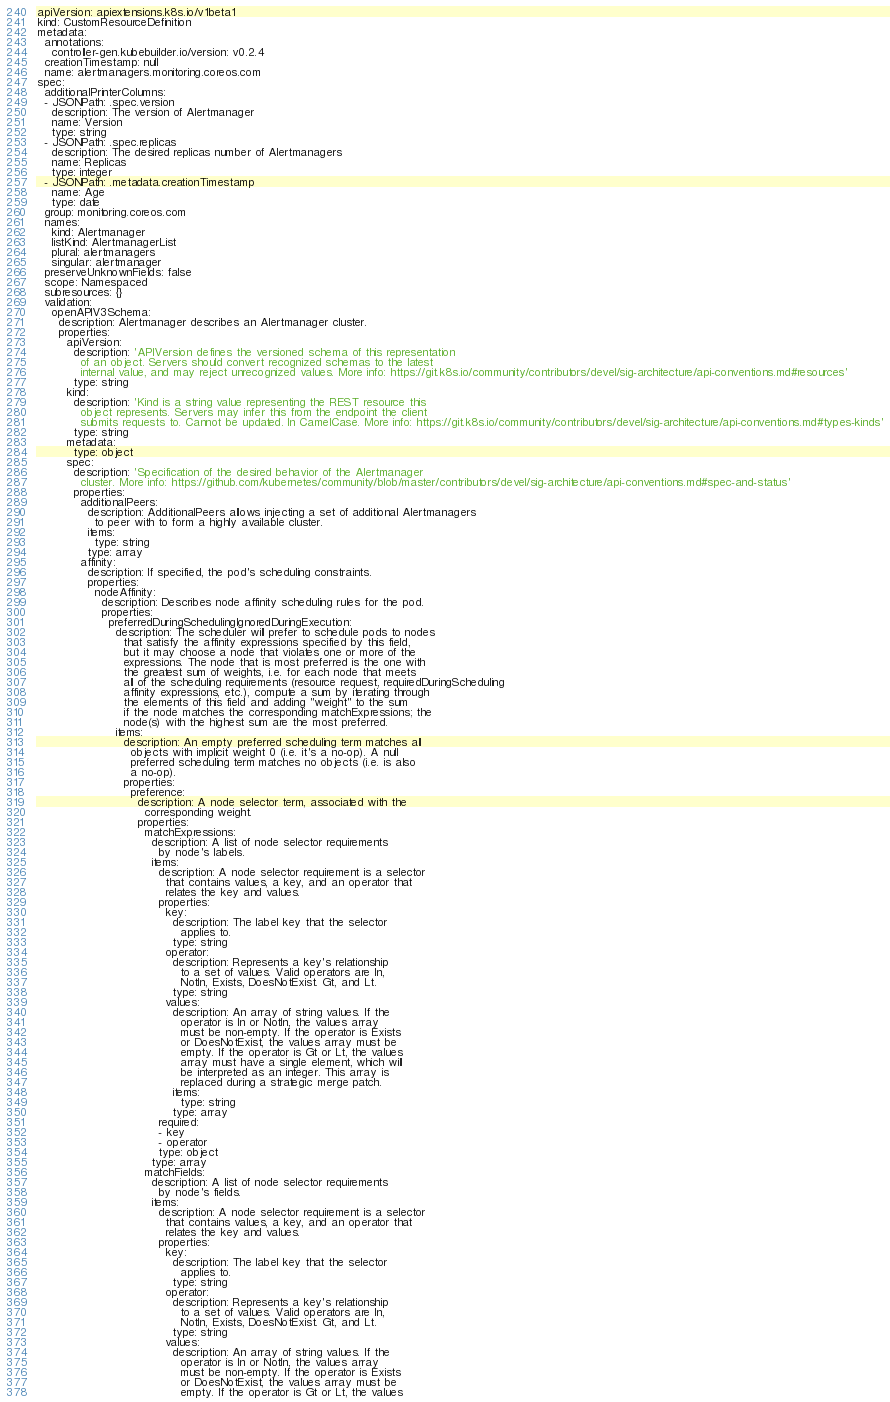Convert code to text. <code><loc_0><loc_0><loc_500><loc_500><_YAML_>apiVersion: apiextensions.k8s.io/v1beta1
kind: CustomResourceDefinition
metadata:
  annotations:
    controller-gen.kubebuilder.io/version: v0.2.4
  creationTimestamp: null
  name: alertmanagers.monitoring.coreos.com
spec:
  additionalPrinterColumns:
  - JSONPath: .spec.version
    description: The version of Alertmanager
    name: Version
    type: string
  - JSONPath: .spec.replicas
    description: The desired replicas number of Alertmanagers
    name: Replicas
    type: integer
  - JSONPath: .metadata.creationTimestamp
    name: Age
    type: date
  group: monitoring.coreos.com
  names:
    kind: Alertmanager
    listKind: AlertmanagerList
    plural: alertmanagers
    singular: alertmanager
  preserveUnknownFields: false
  scope: Namespaced
  subresources: {}
  validation:
    openAPIV3Schema:
      description: Alertmanager describes an Alertmanager cluster.
      properties:
        apiVersion:
          description: 'APIVersion defines the versioned schema of this representation
            of an object. Servers should convert recognized schemas to the latest
            internal value, and may reject unrecognized values. More info: https://git.k8s.io/community/contributors/devel/sig-architecture/api-conventions.md#resources'
          type: string
        kind:
          description: 'Kind is a string value representing the REST resource this
            object represents. Servers may infer this from the endpoint the client
            submits requests to. Cannot be updated. In CamelCase. More info: https://git.k8s.io/community/contributors/devel/sig-architecture/api-conventions.md#types-kinds'
          type: string
        metadata:
          type: object
        spec:
          description: 'Specification of the desired behavior of the Alertmanager
            cluster. More info: https://github.com/kubernetes/community/blob/master/contributors/devel/sig-architecture/api-conventions.md#spec-and-status'
          properties:
            additionalPeers:
              description: AdditionalPeers allows injecting a set of additional Alertmanagers
                to peer with to form a highly available cluster.
              items:
                type: string
              type: array
            affinity:
              description: If specified, the pod's scheduling constraints.
              properties:
                nodeAffinity:
                  description: Describes node affinity scheduling rules for the pod.
                  properties:
                    preferredDuringSchedulingIgnoredDuringExecution:
                      description: The scheduler will prefer to schedule pods to nodes
                        that satisfy the affinity expressions specified by this field,
                        but it may choose a node that violates one or more of the
                        expressions. The node that is most preferred is the one with
                        the greatest sum of weights, i.e. for each node that meets
                        all of the scheduling requirements (resource request, requiredDuringScheduling
                        affinity expressions, etc.), compute a sum by iterating through
                        the elements of this field and adding "weight" to the sum
                        if the node matches the corresponding matchExpressions; the
                        node(s) with the highest sum are the most preferred.
                      items:
                        description: An empty preferred scheduling term matches all
                          objects with implicit weight 0 (i.e. it's a no-op). A null
                          preferred scheduling term matches no objects (i.e. is also
                          a no-op).
                        properties:
                          preference:
                            description: A node selector term, associated with the
                              corresponding weight.
                            properties:
                              matchExpressions:
                                description: A list of node selector requirements
                                  by node's labels.
                                items:
                                  description: A node selector requirement is a selector
                                    that contains values, a key, and an operator that
                                    relates the key and values.
                                  properties:
                                    key:
                                      description: The label key that the selector
                                        applies to.
                                      type: string
                                    operator:
                                      description: Represents a key's relationship
                                        to a set of values. Valid operators are In,
                                        NotIn, Exists, DoesNotExist. Gt, and Lt.
                                      type: string
                                    values:
                                      description: An array of string values. If the
                                        operator is In or NotIn, the values array
                                        must be non-empty. If the operator is Exists
                                        or DoesNotExist, the values array must be
                                        empty. If the operator is Gt or Lt, the values
                                        array must have a single element, which will
                                        be interpreted as an integer. This array is
                                        replaced during a strategic merge patch.
                                      items:
                                        type: string
                                      type: array
                                  required:
                                  - key
                                  - operator
                                  type: object
                                type: array
                              matchFields:
                                description: A list of node selector requirements
                                  by node's fields.
                                items:
                                  description: A node selector requirement is a selector
                                    that contains values, a key, and an operator that
                                    relates the key and values.
                                  properties:
                                    key:
                                      description: The label key that the selector
                                        applies to.
                                      type: string
                                    operator:
                                      description: Represents a key's relationship
                                        to a set of values. Valid operators are In,
                                        NotIn, Exists, DoesNotExist. Gt, and Lt.
                                      type: string
                                    values:
                                      description: An array of string values. If the
                                        operator is In or NotIn, the values array
                                        must be non-empty. If the operator is Exists
                                        or DoesNotExist, the values array must be
                                        empty. If the operator is Gt or Lt, the values</code> 